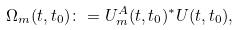<formula> <loc_0><loc_0><loc_500><loc_500>\Omega _ { m } ( t , t _ { 0 } ) \colon = U ^ { A } _ { m } ( t , t _ { 0 } ) ^ { * } U ( t , t _ { 0 } ) ,</formula> 